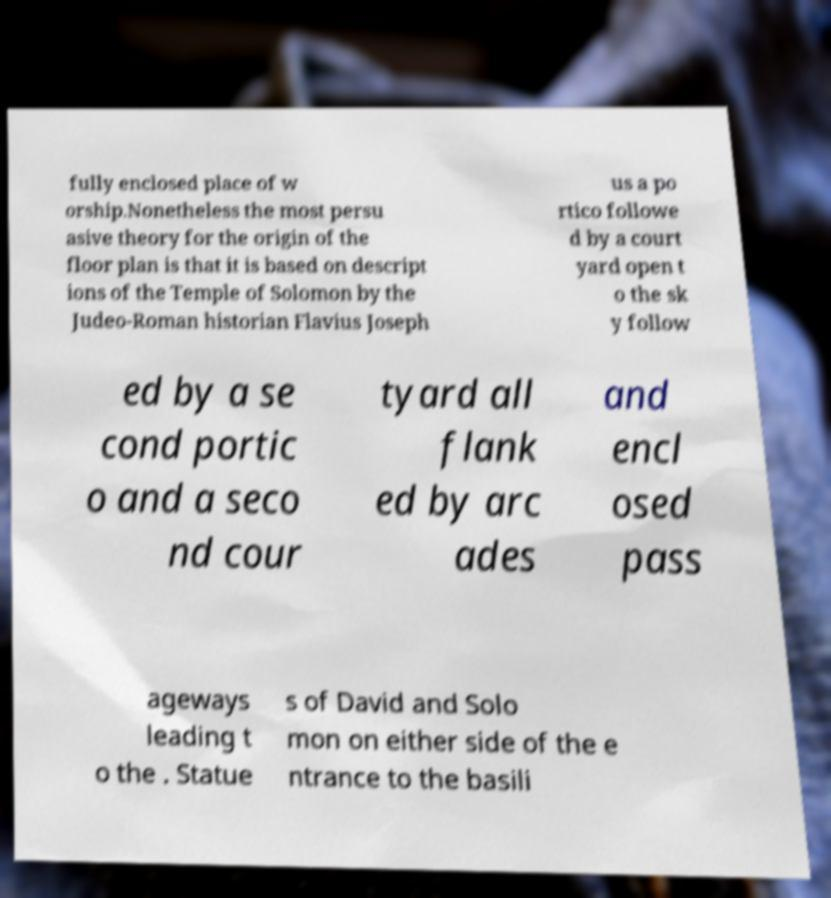Please read and relay the text visible in this image. What does it say? fully enclosed place of w orship.Nonetheless the most persu asive theory for the origin of the floor plan is that it is based on descript ions of the Temple of Solomon by the Judeo-Roman historian Flavius Joseph us a po rtico followe d by a court yard open t o the sk y follow ed by a se cond portic o and a seco nd cour tyard all flank ed by arc ades and encl osed pass ageways leading t o the . Statue s of David and Solo mon on either side of the e ntrance to the basili 